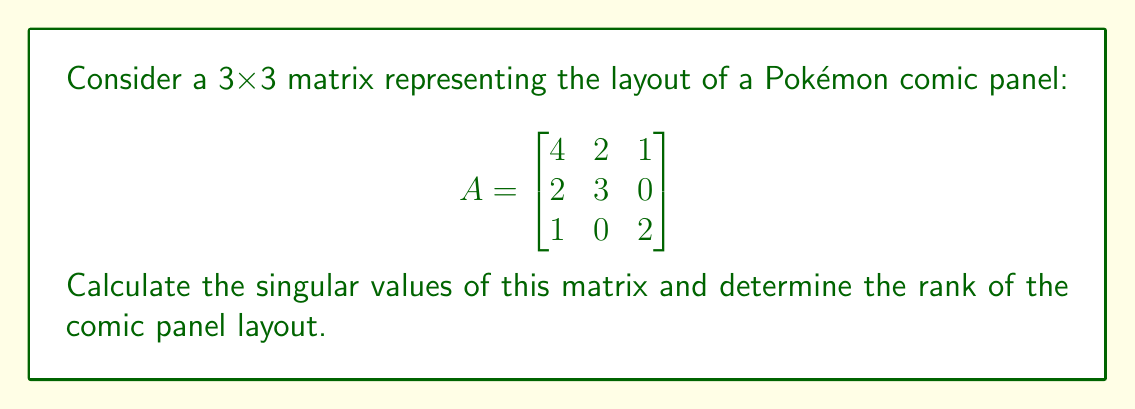Could you help me with this problem? To find the singular values and rank of the matrix A, we'll follow these steps:

1) First, we need to calculate $A^TA$:

   $$A^TA = \begin{bmatrix}
   4 & 2 & 1 \\
   2 & 3 & 0 \\
   1 & 0 & 2
   \end{bmatrix}
   \begin{bmatrix}
   4 & 2 & 1 \\
   2 & 3 & 0 \\
   1 & 0 & 2
   \end{bmatrix}
   = \begin{bmatrix}
   21 & 14 & 6 \\
   14 & 13 & 2 \\
   6 & 2 & 5
   \end{bmatrix}$$

2) Now, we need to find the eigenvalues of $A^TA$. The characteristic equation is:

   $$\det(A^TA - \lambda I) = \begin{vmatrix}
   21-\lambda & 14 & 6 \\
   14 & 13-\lambda & 2 \\
   6 & 2 & 5-\lambda
   \end{vmatrix} = 0$$

3) Expanding this determinant:

   $$-\lambda^3 + 39\lambda^2 - 338\lambda + 630 = 0$$

4) Solving this equation (using a calculator or computer algebra system), we get:

   $$\lambda_1 \approx 33.8656, \lambda_2 \approx 4.9931, \lambda_3 \approx 0.1413$$

5) The singular values are the square roots of these eigenvalues:

   $$\sigma_1 \approx \sqrt{33.8656} \approx 5.8194$$
   $$\sigma_2 \approx \sqrt{4.9931} \approx 2.2346$$
   $$\sigma_3 \approx \sqrt{0.1413} \approx 0.3759$$

6) The rank of the matrix is equal to the number of non-zero singular values. Since all singular values are non-zero (although $\sigma_3$ is small), the rank of A is 3.
Answer: Singular values: $\sigma_1 \approx 5.8194$, $\sigma_2 \approx 2.2346$, $\sigma_3 \approx 0.3759$. Rank: 3. 